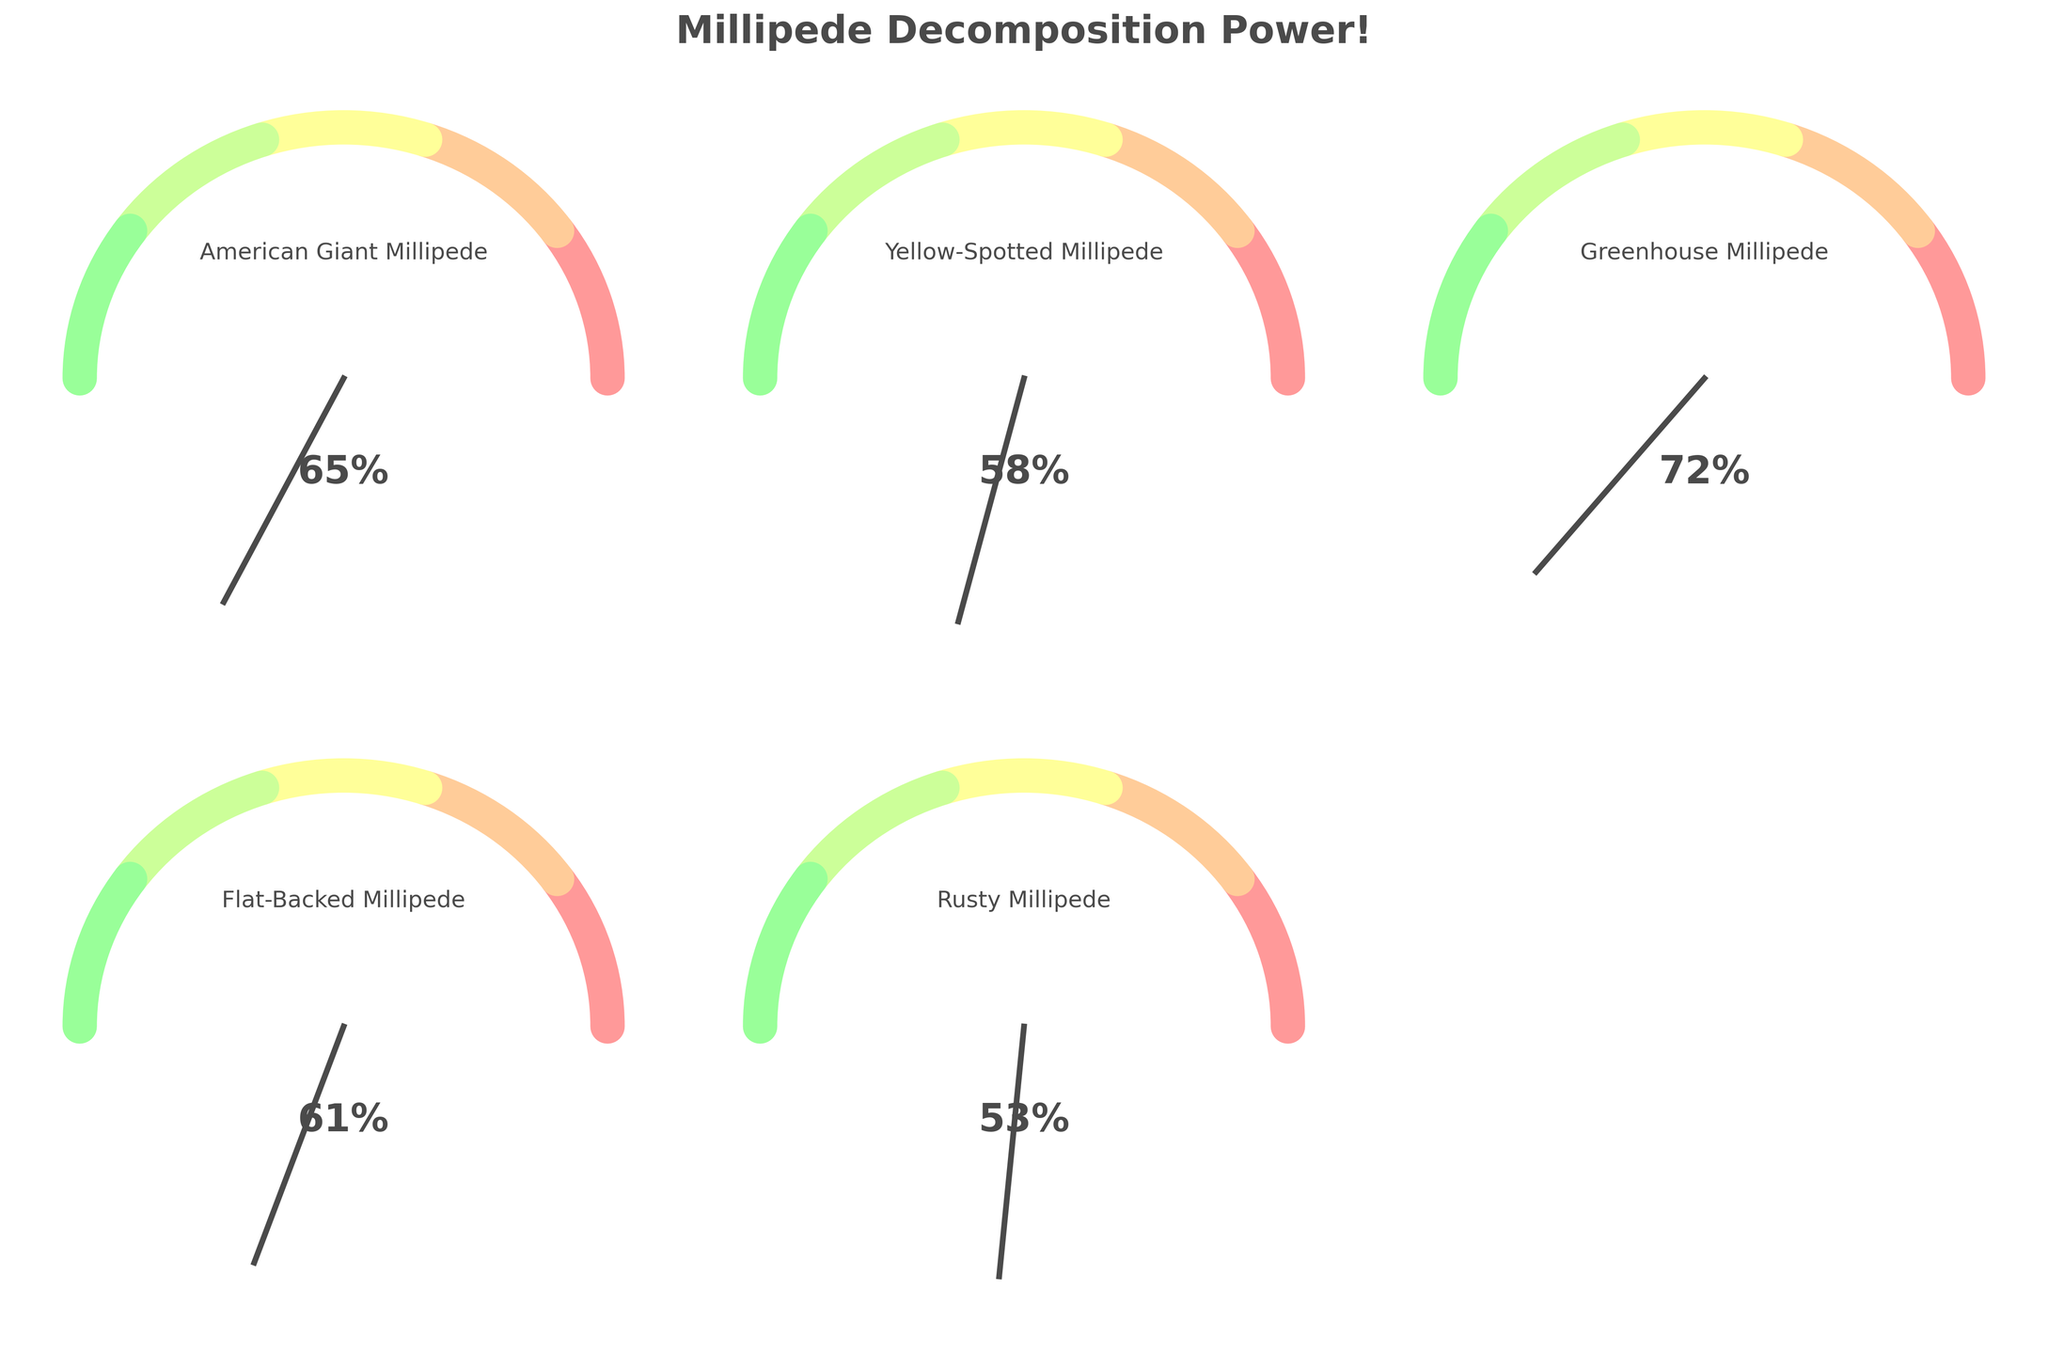What is the title of the figure? The title is usually displayed at the top of the figure. Here it is written in a larger font and catches the viewer's attention with bold formatting.
Answer: Millipede Decomposition Power! How many different millipede species are shown in the figure? You can count the number of gauge charts present. Each chart represents a different species. There are five gauge charts showing five different species.
Answer: Five Which millipede species has the highest decomposition percentage? Locate the gauge charts and compare the indicated percentages. The Greenhouse Millipede has the highest decomposition percentage of 72%.
Answer: Greenhouse Millipede Which millipede species processes 58% of leaf litter? Look at each gauge chart and find the one that indicates 58%. The Yellow-Spotted Millipede is shown with 58%.
Answer: Yellow-Spotted Millipede What is the average percentage of leaf litter processed by all millipede species shown? Add the decomposition percentages: 65% (American Giant) + 58% (Yellow-Spotted) + 72% (Greenhouse) + 61% (Flat-Backed) + 53% (Rusty) = 309%. Now divide by the number of species, which is 5. 309 / 5 = 61.8%.
Answer: 61.8% Which millipede species has a decomposition percentage that is closest to the average? The calculated average is 61.8%. By comparing 65%, 58%, 72%, 61%, and 53%, Flat-Backed Millipede at 61% is closest to the average, as it is only 0.8% away from 61.8%.
Answer: Flat-Backed Millipede Is there any species with a decomposition percentage less than 55%? Compare the decomposition percentages of all species. The Rusty Millipede has 53%, which is less than 55%.
Answer: Rusty Millipede How much more decomposition percentage does the American Giant Millipede have compared to the Rusty Millipede? Subtract the decomposition percentage of the Rusty Millipede (53%) from the American Giant Millipede (65%). 65% - 53% = 12% more.
Answer: 12% Order the millipede species by their decomposition percentages from highest to lowest. Arrange the percentages in descending order: 72% (Greenhouse), 65% (American Giant), 61% (Flat-Backed), 58% (Yellow-Spotted), 53% (Rusty).
Answer: Greenhouse, American Giant, Flat-Backed, Yellow-Spotted, Rusty 